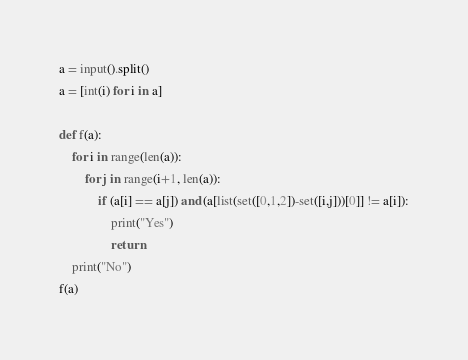Convert code to text. <code><loc_0><loc_0><loc_500><loc_500><_Python_>a = input().split()
a = [int(i) for i in a]

def f(a):
    for i in range(len(a)):
        for j in range(i+1, len(a)):
            if (a[i] == a[j]) and (a[list(set([0,1,2])-set([i,j]))[0]] != a[i]):
                print("Yes")
                return
    print("No")
f(a)</code> 